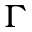Convert formula to latex. <formula><loc_0><loc_0><loc_500><loc_500>\Gamma</formula> 